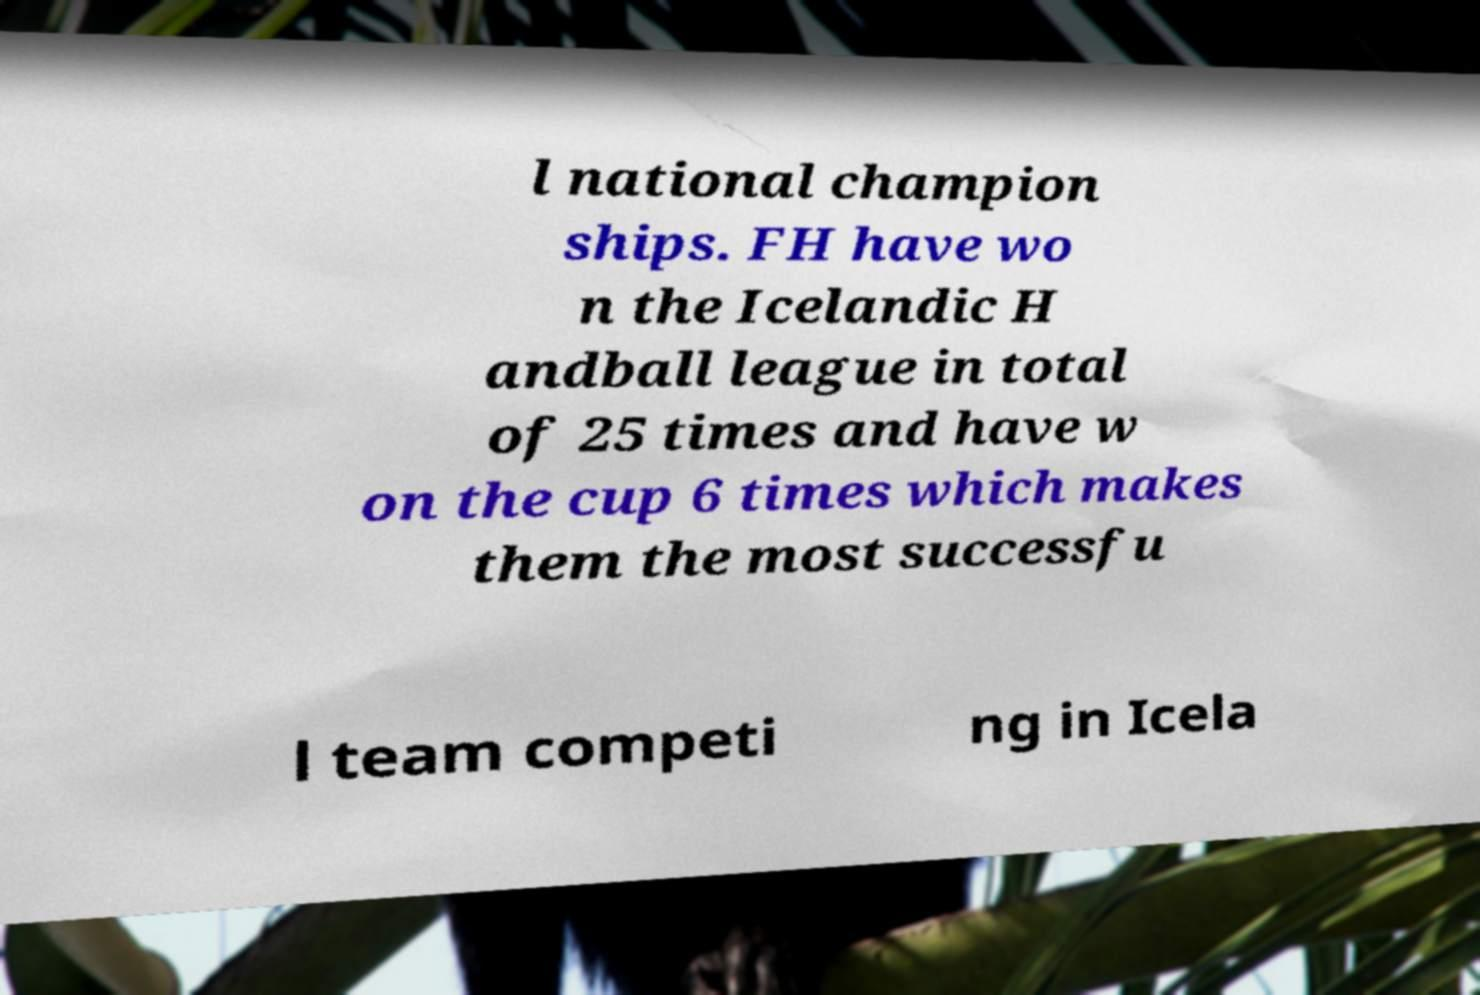There's text embedded in this image that I need extracted. Can you transcribe it verbatim? l national champion ships. FH have wo n the Icelandic H andball league in total of 25 times and have w on the cup 6 times which makes them the most successfu l team competi ng in Icela 